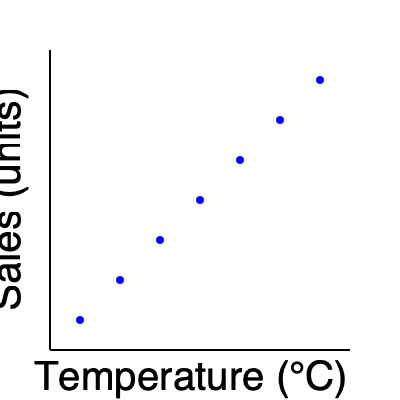As a data analyst, you're examining the relationship between temperature and ice cream sales. Based on the scatter plot, what type of correlation exists between temperature and sales? To determine the type of correlation between temperature and sales, we need to analyze the pattern in the scatter plot:

1. Observe the overall trend: As we move from left to right (increasing temperature), the points move upwards (increasing sales).

2. Check for linearity: The points appear to form a roughly straight line.

3. Assess the direction: The line slopes upward from left to right, indicating a positive relationship.

4. Evaluate the strength: The points are closely aligned to an imaginary straight line, suggesting a strong relationship.

5. Consider outliers: There are no apparent outliers that deviate significantly from the overall pattern.

6. Quantify the relationship: While we can't calculate the exact correlation coefficient without the raw data, visually, this appears to be a strong positive correlation.

Given these observations, we can conclude that there is a strong positive linear correlation between temperature and ice cream sales. As temperature increases, sales tend to increase in a consistent, linear fashion.
Answer: Strong positive linear correlation 